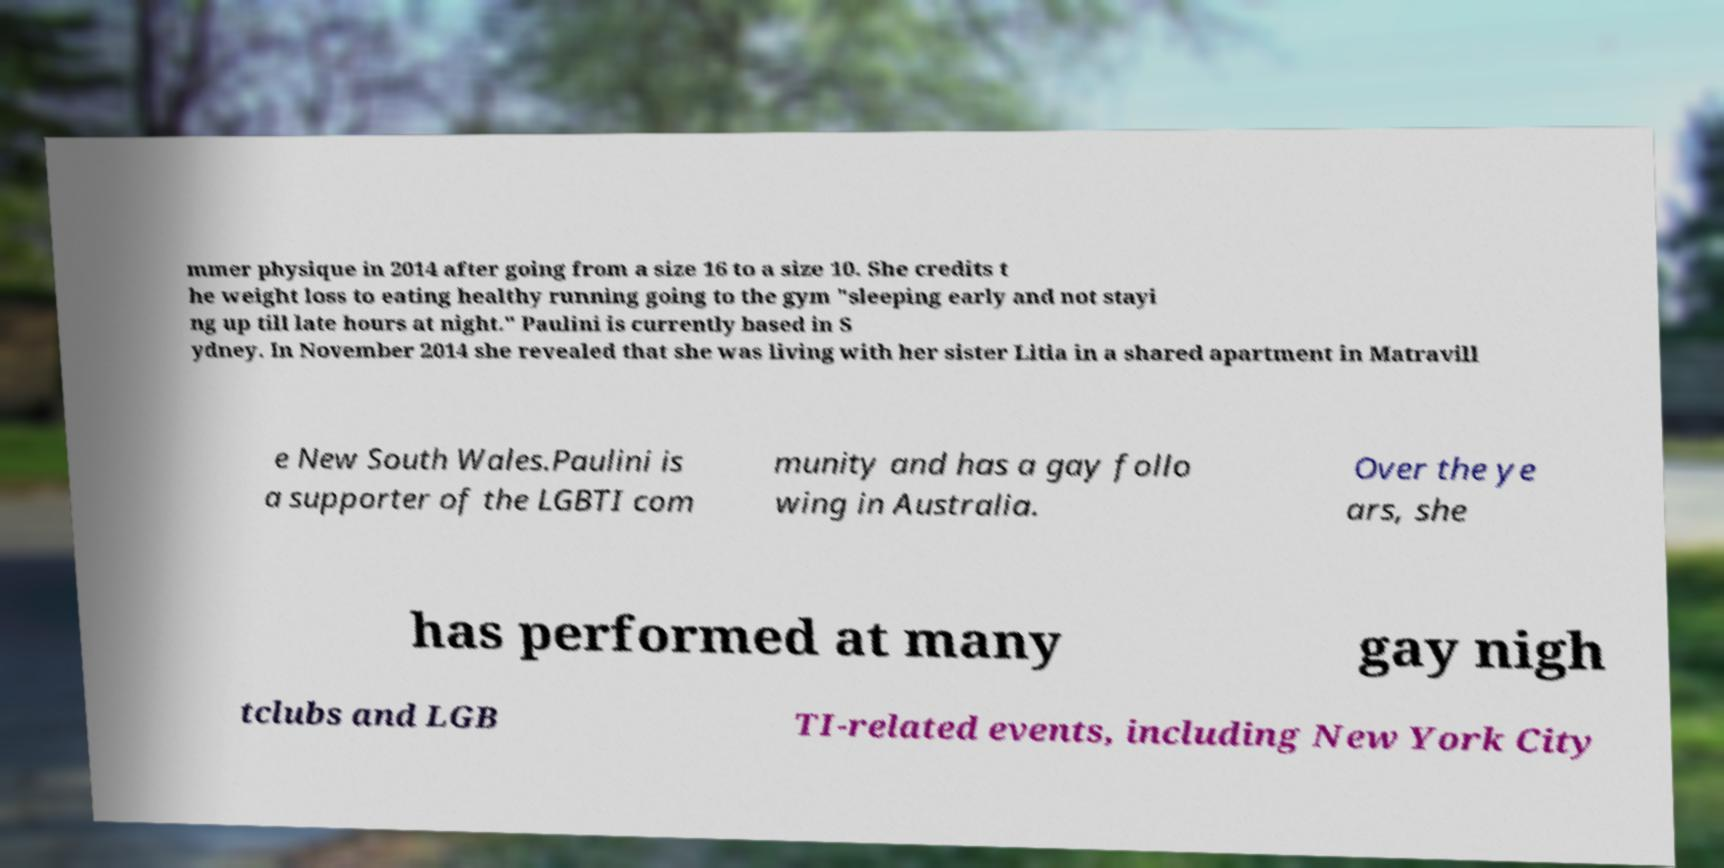Could you extract and type out the text from this image? mmer physique in 2014 after going from a size 16 to a size 10. She credits t he weight loss to eating healthy running going to the gym "sleeping early and not stayi ng up till late hours at night." Paulini is currently based in S ydney. In November 2014 she revealed that she was living with her sister Litia in a shared apartment in Matravill e New South Wales.Paulini is a supporter of the LGBTI com munity and has a gay follo wing in Australia. Over the ye ars, she has performed at many gay nigh tclubs and LGB TI-related events, including New York City 